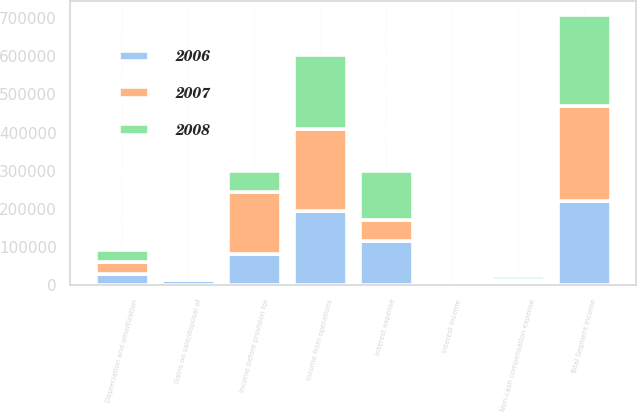Convert chart to OTSL. <chart><loc_0><loc_0><loc_500><loc_500><stacked_bar_chart><ecel><fcel>Total Segment Income<fcel>Depreciation and amortization<fcel>Gains on sale/disposal of<fcel>Non-cash compensation expense<fcel>Income from operations<fcel>Interest income<fcel>Interest expense<fcel>Income before provision for<nl><fcel>2007<fcel>249003<fcel>32266<fcel>2678<fcel>5218<fcel>214197<fcel>1239<fcel>55011<fcel>160425<nl><fcel>2008<fcel>239326<fcel>31176<fcel>766<fcel>8405<fcel>193910<fcel>5317<fcel>130374<fcel>55559<nl><fcel>2006<fcel>220159<fcel>28377<fcel>13752<fcel>9059<fcel>195030<fcel>2746<fcel>114906<fcel>82870<nl></chart> 